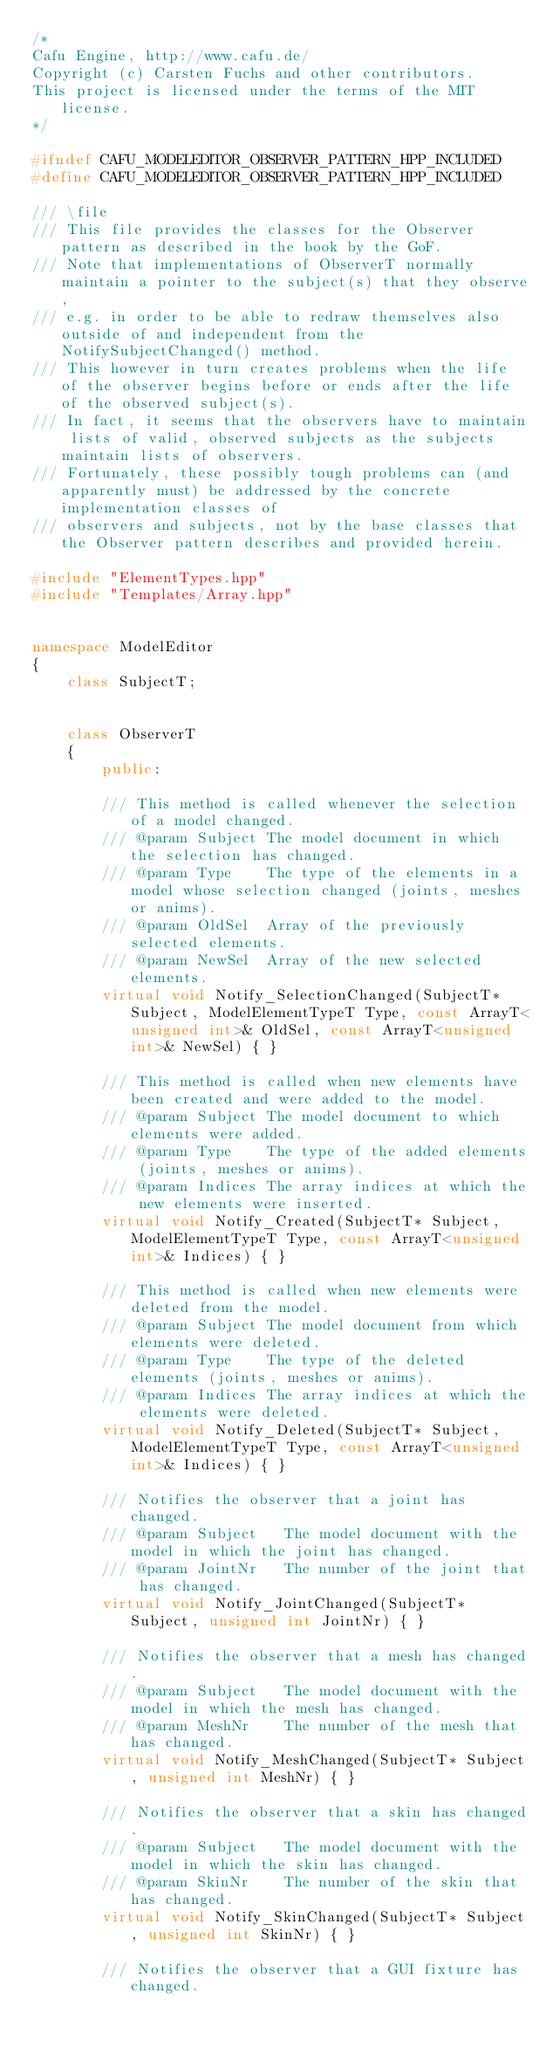Convert code to text. <code><loc_0><loc_0><loc_500><loc_500><_C++_>/*
Cafu Engine, http://www.cafu.de/
Copyright (c) Carsten Fuchs and other contributors.
This project is licensed under the terms of the MIT license.
*/

#ifndef CAFU_MODELEDITOR_OBSERVER_PATTERN_HPP_INCLUDED
#define CAFU_MODELEDITOR_OBSERVER_PATTERN_HPP_INCLUDED

/// \file
/// This file provides the classes for the Observer pattern as described in the book by the GoF.
/// Note that implementations of ObserverT normally maintain a pointer to the subject(s) that they observe,
/// e.g. in order to be able to redraw themselves also outside of and independent from the NotifySubjectChanged() method.
/// This however in turn creates problems when the life of the observer begins before or ends after the life of the observed subject(s).
/// In fact, it seems that the observers have to maintain lists of valid, observed subjects as the subjects maintain lists of observers.
/// Fortunately, these possibly tough problems can (and apparently must) be addressed by the concrete implementation classes of
/// observers and subjects, not by the base classes that the Observer pattern describes and provided herein.

#include "ElementTypes.hpp"
#include "Templates/Array.hpp"


namespace ModelEditor
{
    class SubjectT;


    class ObserverT
    {
        public:

        /// This method is called whenever the selection of a model changed.
        /// @param Subject The model document in which the selection has changed.
        /// @param Type    The type of the elements in a model whose selection changed (joints, meshes or anims).
        /// @param OldSel  Array of the previously selected elements.
        /// @param NewSel  Array of the new selected elements.
        virtual void Notify_SelectionChanged(SubjectT* Subject, ModelElementTypeT Type, const ArrayT<unsigned int>& OldSel, const ArrayT<unsigned int>& NewSel) { }

        /// This method is called when new elements have been created and were added to the model.
        /// @param Subject The model document to which elements were added.
        /// @param Type    The type of the added elements (joints, meshes or anims).
        /// @param Indices The array indices at which the new elements were inserted.
        virtual void Notify_Created(SubjectT* Subject, ModelElementTypeT Type, const ArrayT<unsigned int>& Indices) { }

        /// This method is called when new elements were deleted from the model.
        /// @param Subject The model document from which elements were deleted.
        /// @param Type    The type of the deleted elements (joints, meshes or anims).
        /// @param Indices The array indices at which the elements were deleted.
        virtual void Notify_Deleted(SubjectT* Subject, ModelElementTypeT Type, const ArrayT<unsigned int>& Indices) { }

        /// Notifies the observer that a joint has changed.
        /// @param Subject   The model document with the model in which the joint has changed.
        /// @param JointNr   The number of the joint that has changed.
        virtual void Notify_JointChanged(SubjectT* Subject, unsigned int JointNr) { }

        /// Notifies the observer that a mesh has changed.
        /// @param Subject   The model document with the model in which the mesh has changed.
        /// @param MeshNr    The number of the mesh that has changed.
        virtual void Notify_MeshChanged(SubjectT* Subject, unsigned int MeshNr) { }

        /// Notifies the observer that a skin has changed.
        /// @param Subject   The model document with the model in which the skin has changed.
        /// @param SkinNr    The number of the skin that has changed.
        virtual void Notify_SkinChanged(SubjectT* Subject, unsigned int SkinNr) { }

        /// Notifies the observer that a GUI fixture has changed.</code> 